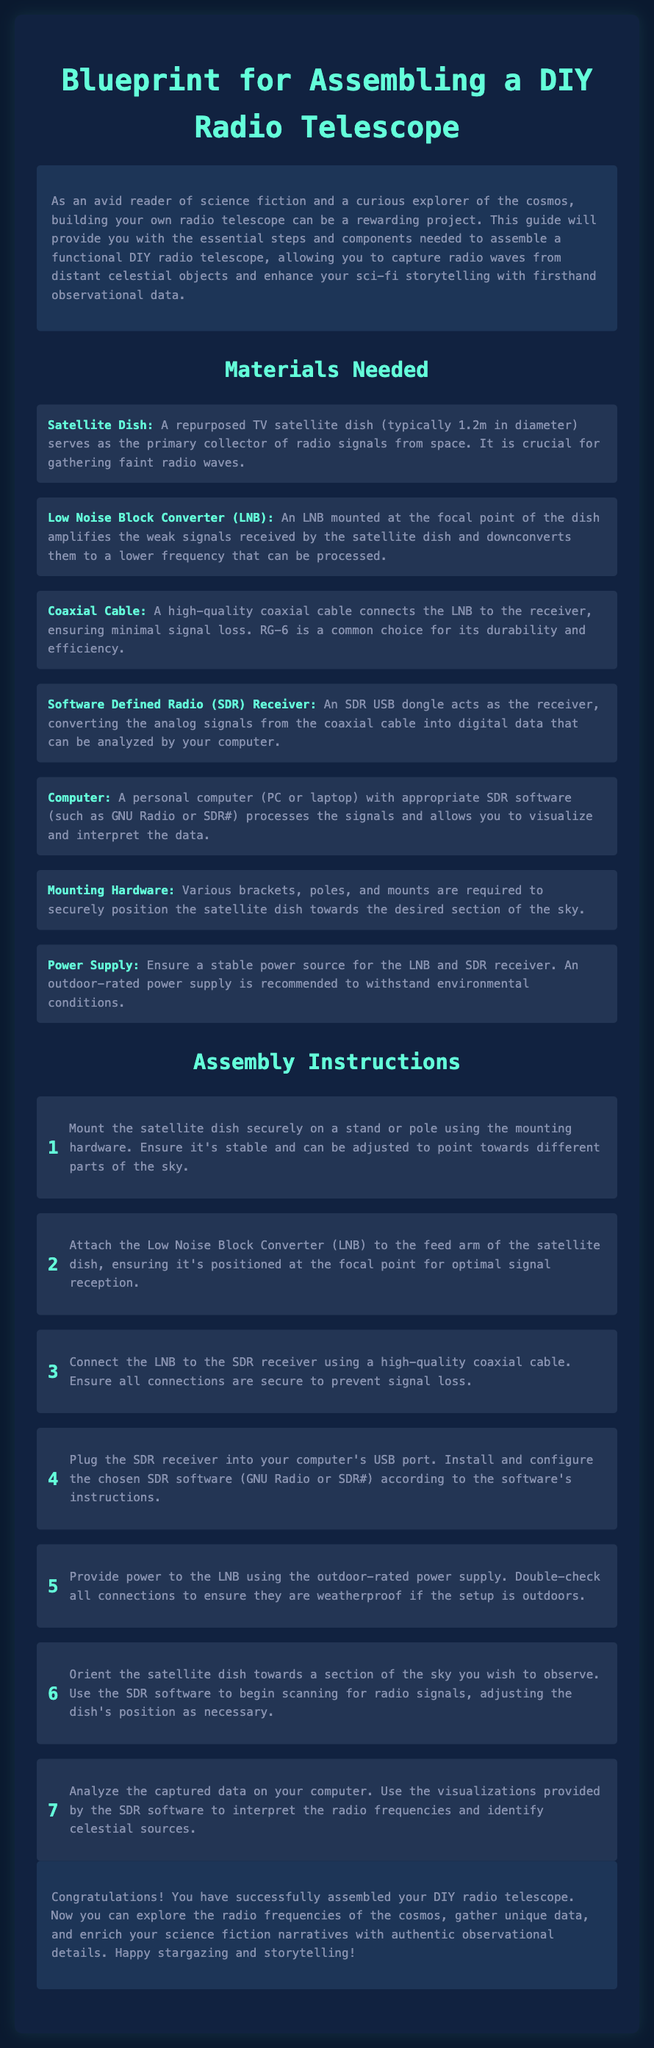What is the primary component used to collect radio signals? The primary collector of radio signals from space is the satellite dish, which is typically 1.2m in diameter.
Answer: Satellite dish What does the LNB do? The LNB amplifies the weak signals received by the satellite dish and downconverts them to a lower frequency that can be processed.
Answer: Amplifies and downconverts signals What type of cable is recommended for connecting the LNB to the receiver? A high-quality coaxial cable is necessary to connect the LNB to the receiver, with RG-6 being a common choice for its durability and efficiency.
Answer: Coaxial cable How many assembly steps are provided in the instructions? The instructions provide a total of seven assembly steps for constructing the DIY radio telescope.
Answer: Seven What should be used to ensure a stable power source for the components? An outdoor-rated power supply is recommended to ensure a stable power source for the LNB and SDR receiver.
Answer: Power supply Which software can be utilized for processing signals? The document mentions GNU Radio or SDR# as appropriate SDR software for processing signals from the telescope.
Answer: GNU Radio or SDR# What is the purpose of mounting hardware in this project? Mounting hardware is required to securely position the satellite dish towards the desired section of the sky.
Answer: Secure positioning What is the conclusion of the assembly instructions? The conclusion states that the successful assembly allows users to explore radio frequencies and enhance their science fiction narratives with authentic data.
Answer: Successful assembly allows exploration of radio frequencies 